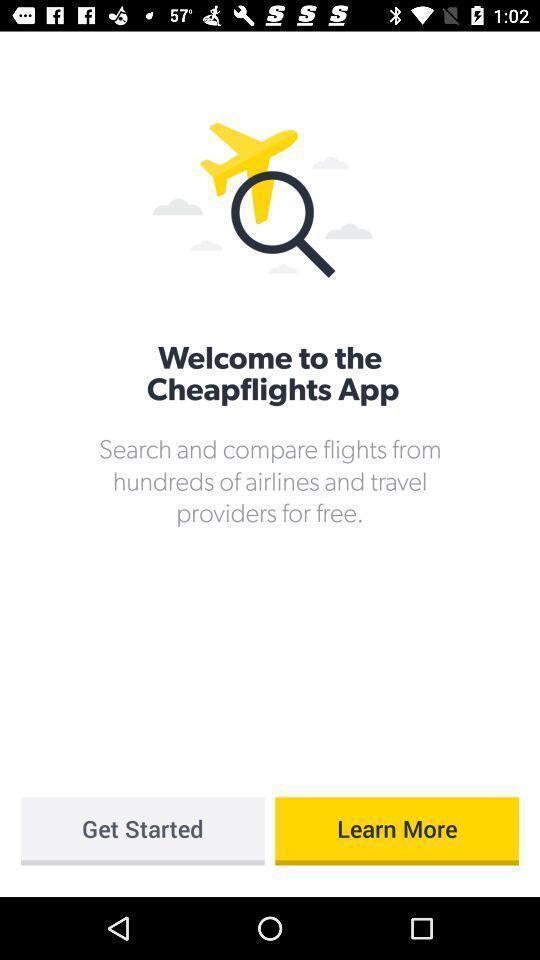What details can you identify in this image? Welcome page of a travel application. 